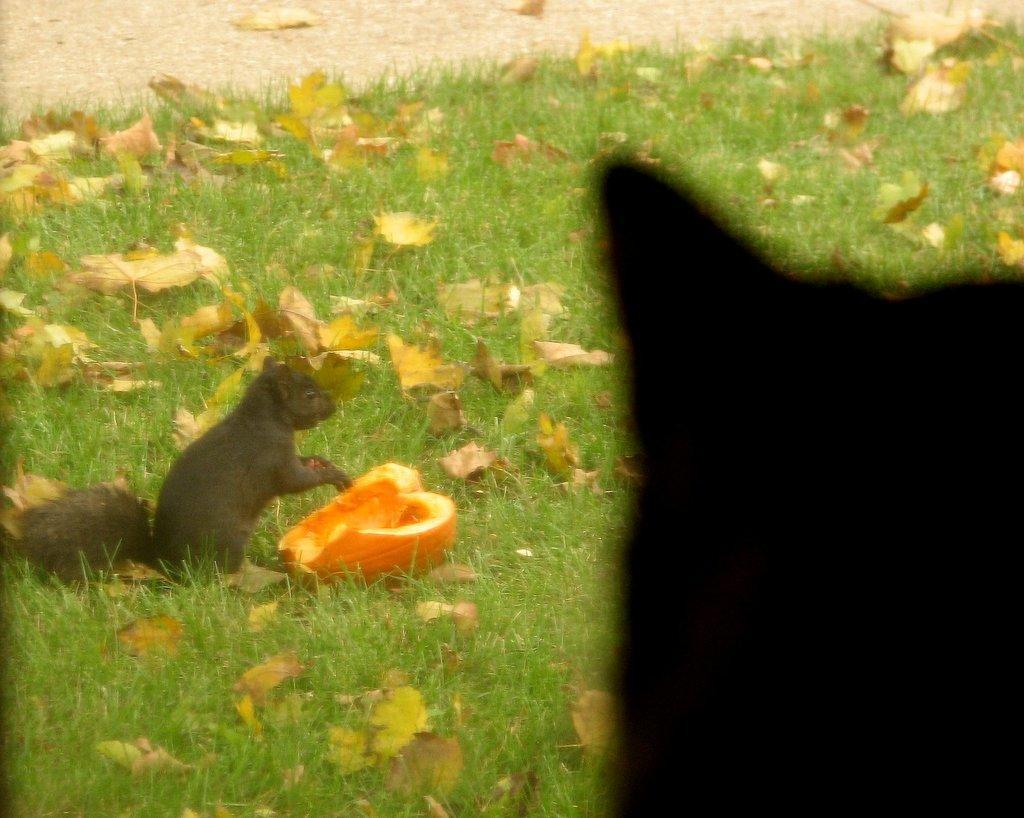Can you describe this image briefly? In this image, we can see some grass and leaves. There is a squirrel on the left side of the image. There is a pumpkin in the middle of the image. 